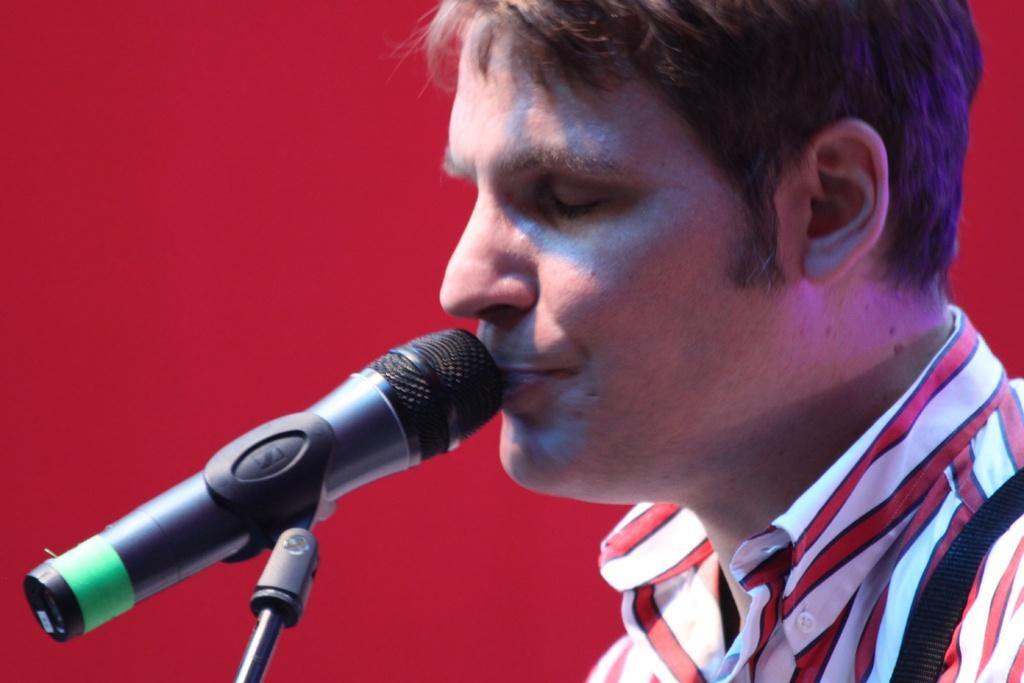What is the main subject of the image? There is a person in the image. What is the person doing in the image? The person's lips are near a microphone. What color is the background of the image? The background of the image is red. How many roses can be seen in the image? There are no roses present in the image. What type of zipper is being used by the person in the image? There is no zipper visible in the image. 